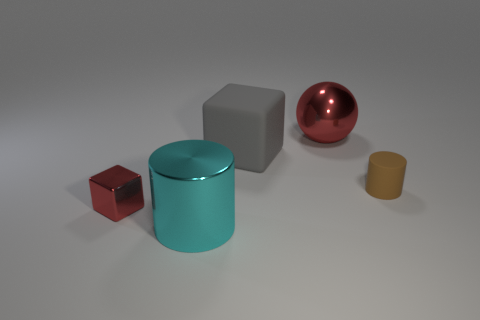Add 4 cyan metallic objects. How many objects exist? 9 Subtract all cubes. How many objects are left? 3 Subtract all tiny spheres. Subtract all cyan cylinders. How many objects are left? 4 Add 2 big metallic objects. How many big metallic objects are left? 4 Add 5 tiny gray cubes. How many tiny gray cubes exist? 5 Subtract 0 cyan spheres. How many objects are left? 5 